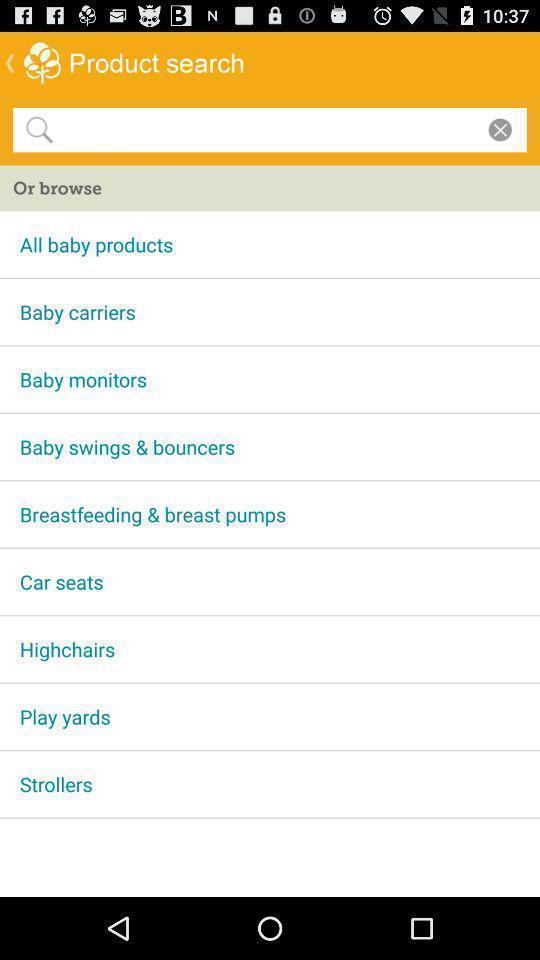Explain the elements present in this screenshot. Search bar to find baby care products. 